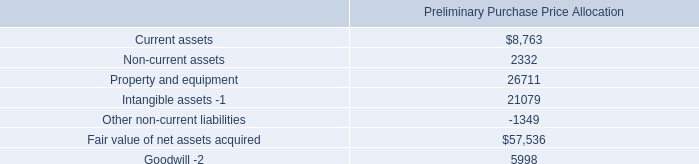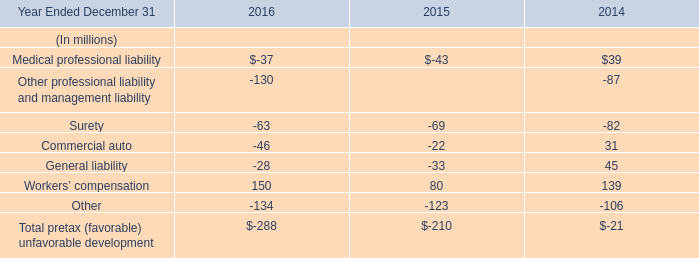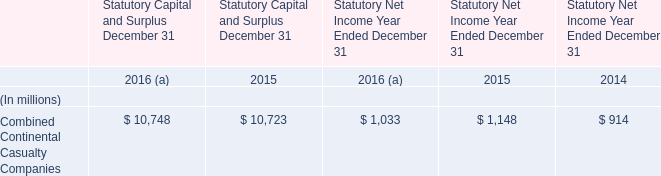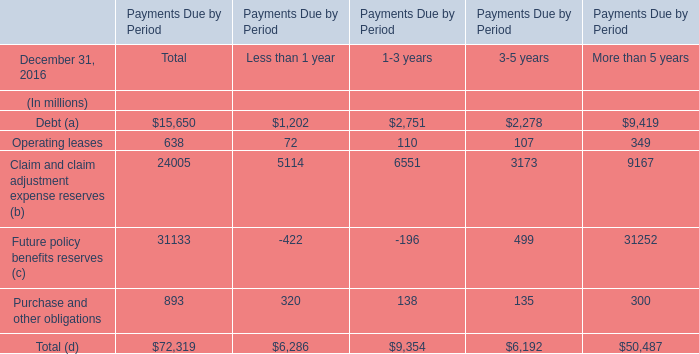What is the value of the Claim and claim adjustment expense reserves for 1-3 years? (in million) 
Answer: 6551. 